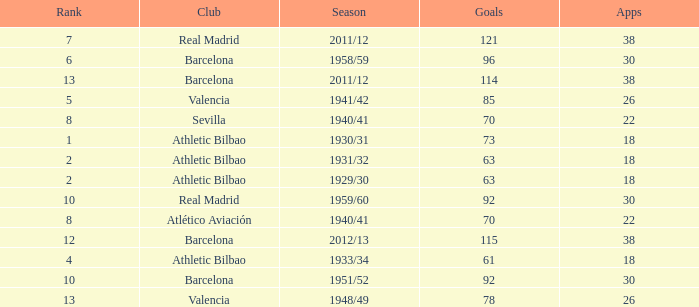How many apps when the rank was after 13 and having more than 73 goals? None. 